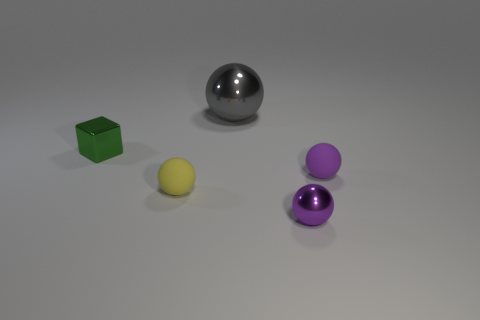Is there anything else that is the same size as the gray shiny sphere?
Give a very brief answer. No. What number of things are small purple shiny objects or big gray metallic objects?
Your answer should be very brief. 2. The small purple object behind the rubber sphere left of the purple metal thing is made of what material?
Ensure brevity in your answer.  Rubber. Are there any other spheres that have the same color as the tiny metallic sphere?
Make the answer very short. Yes. What color is the other matte sphere that is the same size as the purple rubber sphere?
Your answer should be compact. Yellow. The object behind the green thing behind the metal thing on the right side of the big ball is made of what material?
Make the answer very short. Metal. Is the color of the tiny metallic sphere the same as the small matte thing on the right side of the small yellow sphere?
Make the answer very short. Yes. What number of things are things that are to the left of the yellow matte ball or tiny matte things on the left side of the gray object?
Your response must be concise. 2. What is the shape of the rubber object that is on the left side of the metal thing that is behind the tiny green metallic thing?
Provide a succinct answer. Sphere. Is there a large blue object that has the same material as the block?
Your answer should be compact. No. 